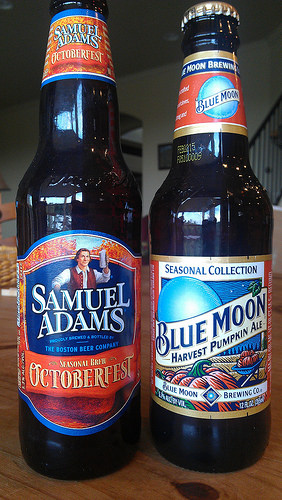<image>
Is there a beer next to the beer? Yes. The beer is positioned adjacent to the beer, located nearby in the same general area. Where is the coca cola in relation to the pepsi? Is it next to the pepsi? No. The coca cola is not positioned next to the pepsi. They are located in different areas of the scene. Is there a man on the beer bottle? Yes. Looking at the image, I can see the man is positioned on top of the beer bottle, with the beer bottle providing support. 